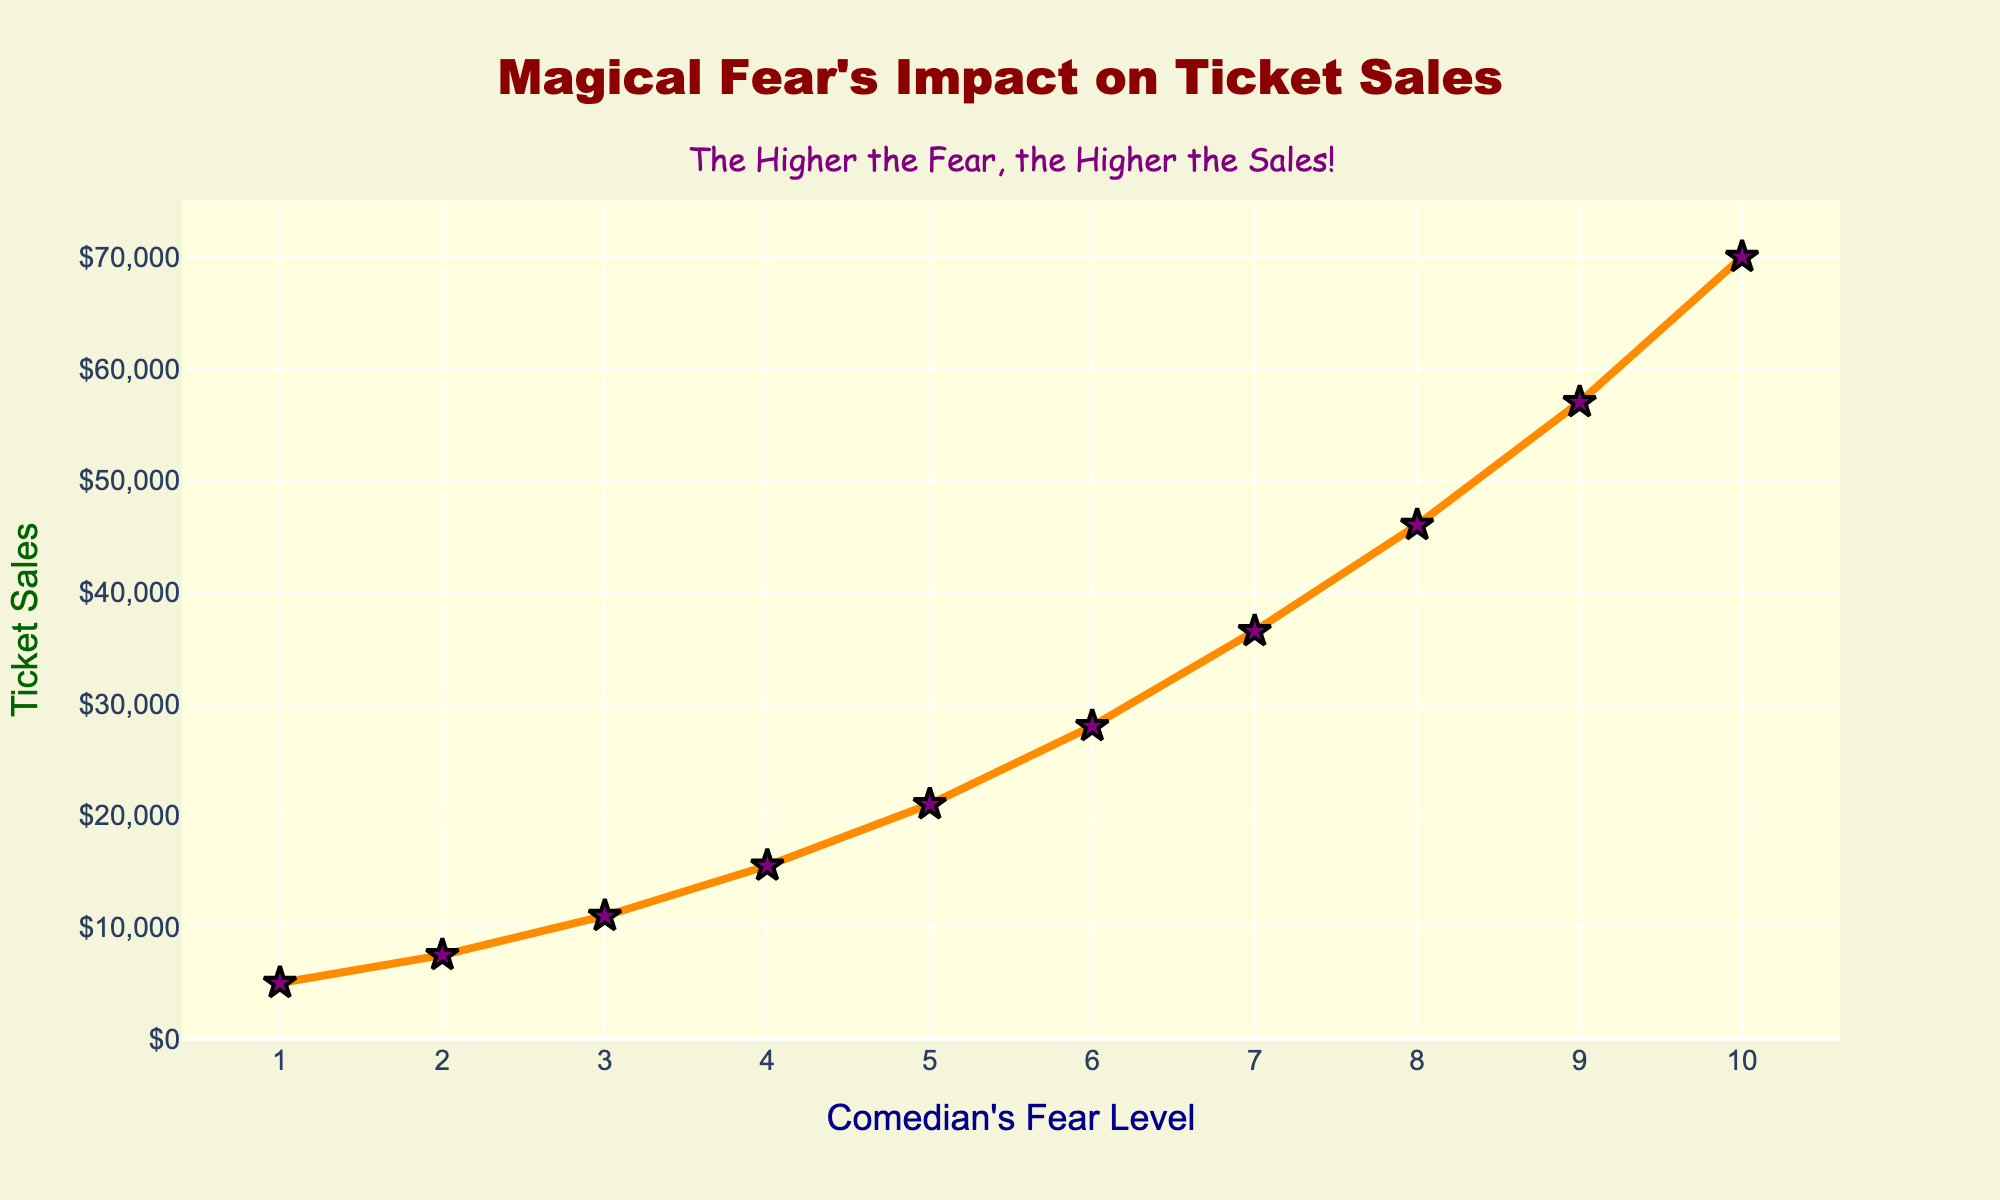What's the highest ticket sales value observed in the figure? Locate the highest point on the line chart. The y-value at this point represents the highest ticket sales, which is 70,000.
Answer: 70,000 How does the fear level correlate with ticket sales according to the figure? Observe the trend of the line chart. As the fear level increases from 1 to 10, the ticket sales consistently rise, indicating a positive correlation.
Answer: Positive correlation By how much does the ticket sales increase when the fear level rises from 5 to 6? Refer to the y-values corresponding to fear levels 5 and 6. Ticket sales at fear level 5 are 21,000, and at fear level 6 are 28,000. The increase is 28,000 - 21,000 = 7,000.
Answer: 7,000 What is the average ticket sales for fear levels spanning from 1 to 5? Sum the ticket sales for fear levels 1 to 5: (5,000 + 7,500 + 11,000 + 15,500 + 21,000) = 60,000. Then divide by the number of levels (5), so the average is 60,000 / 5 = 12,000.
Answer: 12,000 Which color and shape are used to represent the data points in the figure? The visual attributes of the data points in the figure are stars colored in purple with a black outline.
Answer: Purple stars What is the ticket sales value at a fear level of 7? Locate the data point on the line chart where the fear level is 7. The corresponding y-value is 36,500.
Answer: 36,500 How much more are the ticket sales at a fear level of 10 compared to a fear level of 2? Compare the ticket sales at fear level 10 (70,000) and fear level 2 (7,500). The difference is 70,000 - 7,500 = 62,500.
Answer: 62,500 What appears to be the annotation message included in the figure? Review the textual annotation in the figure, which states: "The Higher the Fear, the Higher the Sales!"
Answer: The Higher the Fear, the Higher the Sales! Which fear level shows the most significant incremental increase in ticket sales from its preceding level? Calculate the differences in ticket sales between each consecutive fear level. The most significant increase occurs between fear levels 9 and 10 (70,000 - 57,000 = 13,000).
Answer: From 9 to 10 How does the background color of the plot describe the figure's theme? The plot's background color is light yellow, and the paper background is beige. These warm colors help soften the visual, making the theme appear less ominous and more humorous.
Answer: Light yellow and beige 